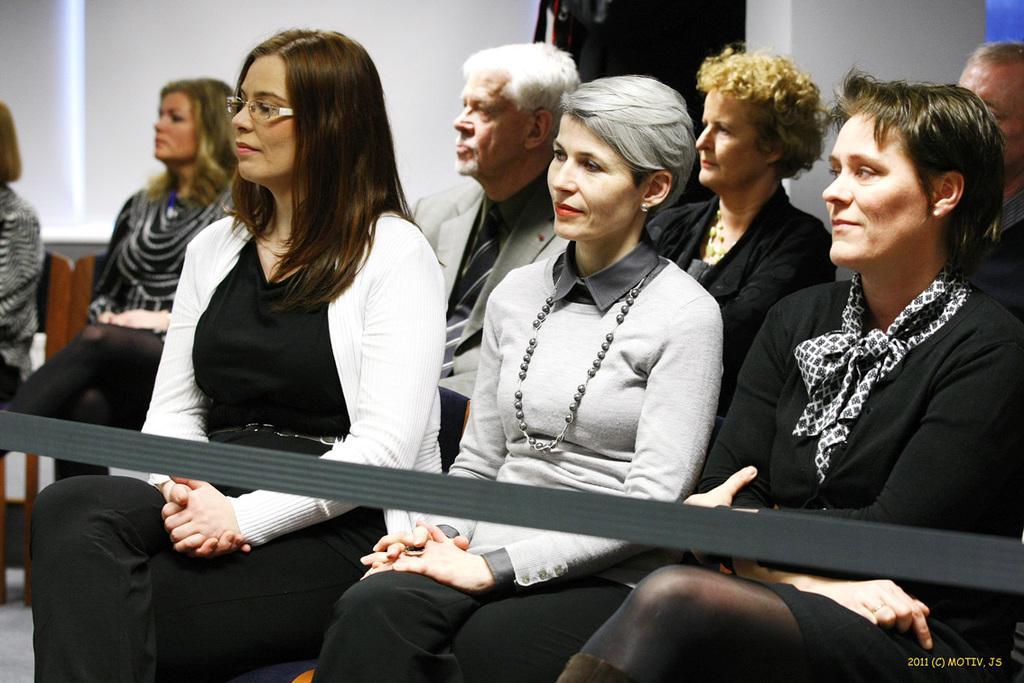Could you give a brief overview of what you see in this image? In this image we can see these people are sitting on the chairs. Here we can see the rope. In the background, we can see the white color wall. 